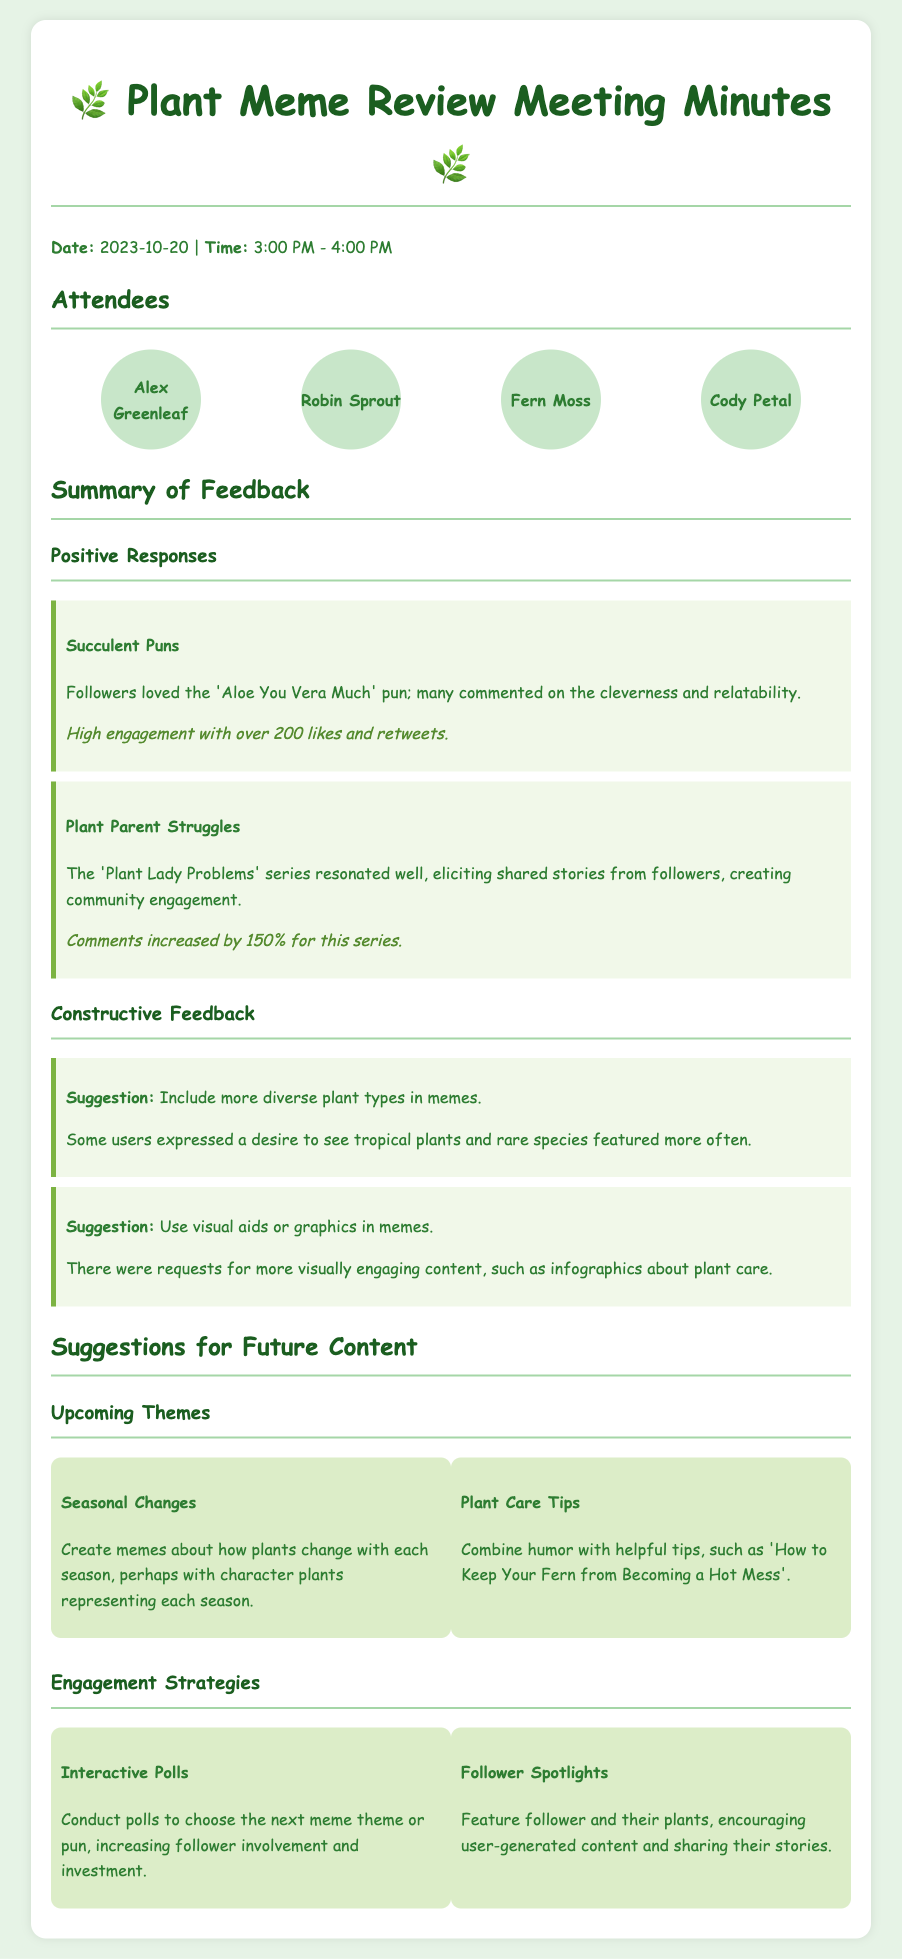What is the date of the meeting? The date of the meeting is mentioned in the document under the date heading.
Answer: 2023-10-20 How many attendees were present? The number of attendees can be counted from the listed names in the attendees section.
Answer: 4 What meme was particularly liked by followers? The document lists specific feedback about memes that were well-received, including this one.
Answer: Aloe You Vera Much What was the percentage increase in comments for the 'Plant Lady Problems' series? This information can be found in the positive responses section detailing the impact of that series on engagement.
Answer: 150% What are the two upcoming themes mentioned for future content? The document offers specific suggestions for themes to explore in future memes.
Answer: Seasonal Changes and Plant Care Tips What engagement strategy involves conducting polls? The strategies outlined in the future content section provide ways to engage followers.
Answer: Interactive Polls Which plant type was suggested to feature more in memes? The feedback section includes suggestions from users requesting variety in plant types portrayed.
Answer: Tropical plants How many likes and retweets did the 'Aloe You Vera Much' pun receive? The engagement metrics are specified for this particular meme in the positive responses.
Answer: Over 200 likes and retweets 